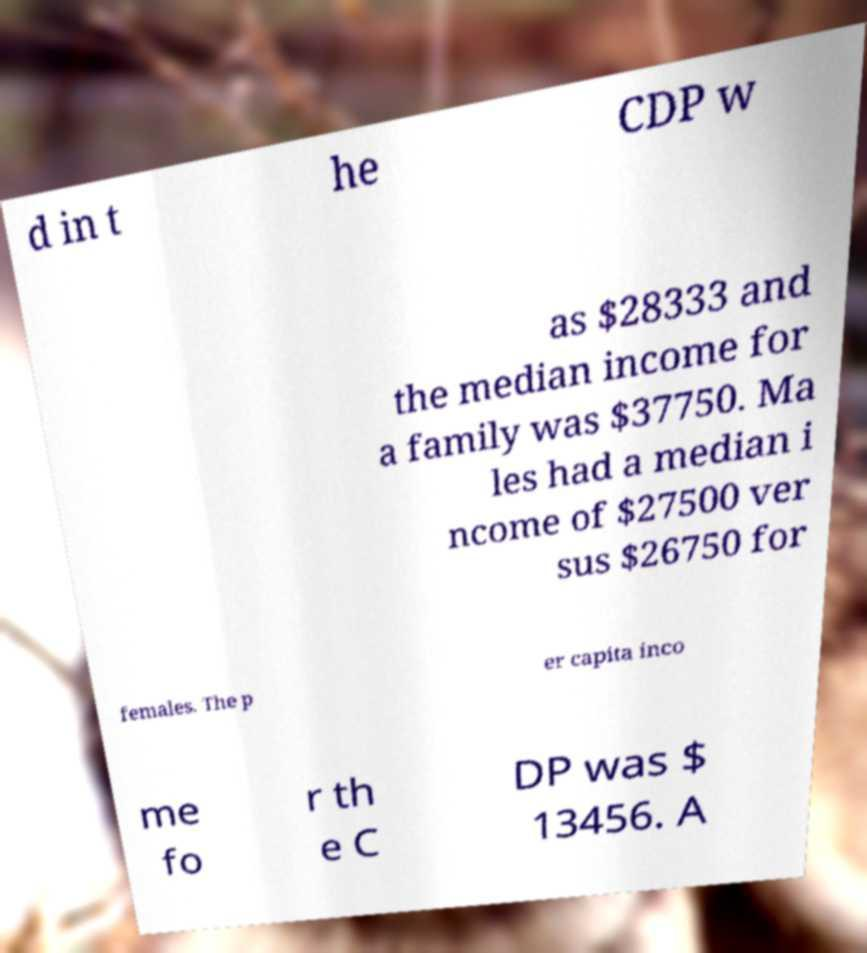There's text embedded in this image that I need extracted. Can you transcribe it verbatim? d in t he CDP w as $28333 and the median income for a family was $37750. Ma les had a median i ncome of $27500 ver sus $26750 for females. The p er capita inco me fo r th e C DP was $ 13456. A 